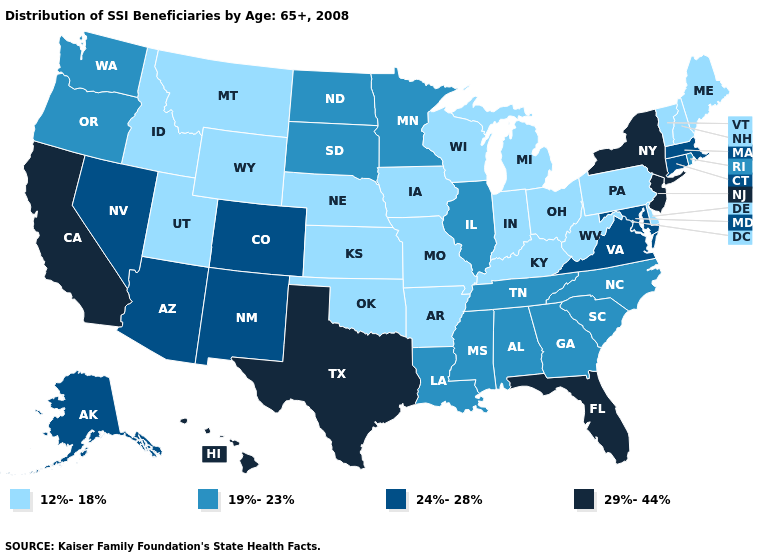Does North Dakota have the highest value in the USA?
Short answer required. No. How many symbols are there in the legend?
Concise answer only. 4. Name the states that have a value in the range 29%-44%?
Write a very short answer. California, Florida, Hawaii, New Jersey, New York, Texas. Does New Hampshire have a lower value than New Mexico?
Answer briefly. Yes. Is the legend a continuous bar?
Answer briefly. No. Does the first symbol in the legend represent the smallest category?
Write a very short answer. Yes. What is the lowest value in the Northeast?
Concise answer only. 12%-18%. Does North Carolina have the same value as Oregon?
Keep it brief. Yes. Does Michigan have the highest value in the MidWest?
Concise answer only. No. Name the states that have a value in the range 24%-28%?
Write a very short answer. Alaska, Arizona, Colorado, Connecticut, Maryland, Massachusetts, Nevada, New Mexico, Virginia. Which states have the lowest value in the USA?
Answer briefly. Arkansas, Delaware, Idaho, Indiana, Iowa, Kansas, Kentucky, Maine, Michigan, Missouri, Montana, Nebraska, New Hampshire, Ohio, Oklahoma, Pennsylvania, Utah, Vermont, West Virginia, Wisconsin, Wyoming. Among the states that border Georgia , does Florida have the highest value?
Short answer required. Yes. What is the value of Oklahoma?
Concise answer only. 12%-18%. Name the states that have a value in the range 29%-44%?
Short answer required. California, Florida, Hawaii, New Jersey, New York, Texas. Does the first symbol in the legend represent the smallest category?
Short answer required. Yes. 